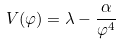Convert formula to latex. <formula><loc_0><loc_0><loc_500><loc_500>V ( \varphi ) = \lambda - \frac { \alpha } { \varphi ^ { 4 } }</formula> 